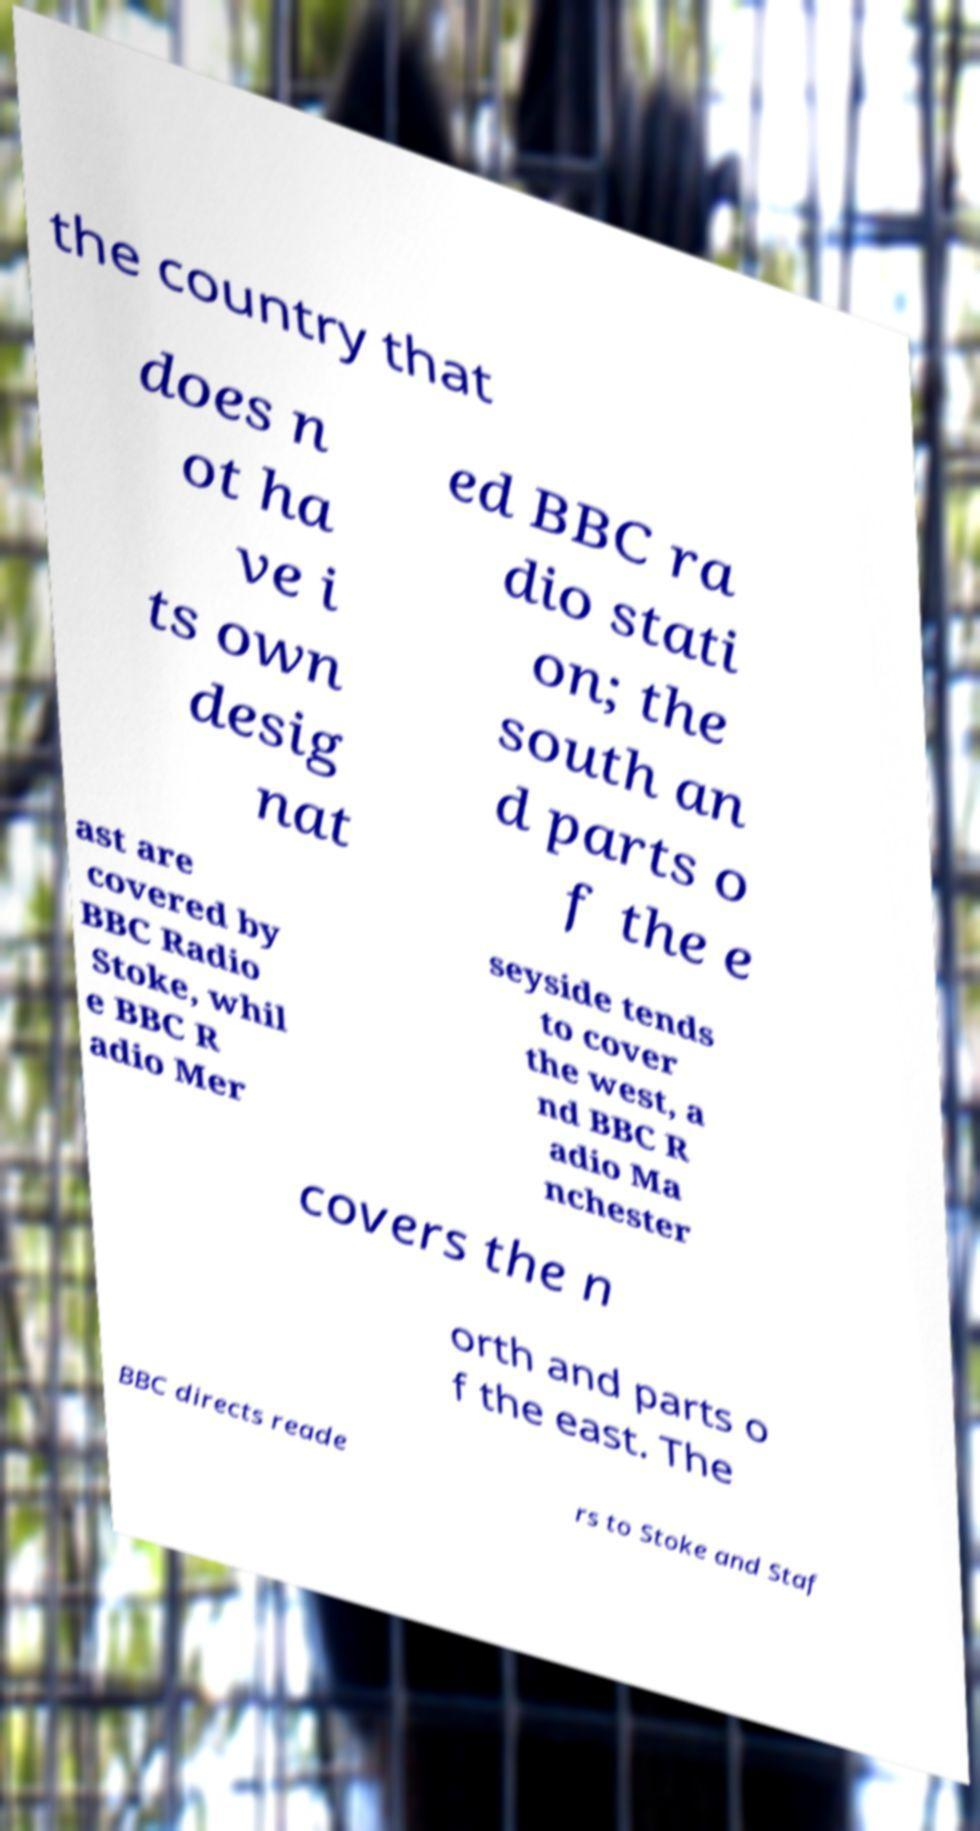Can you accurately transcribe the text from the provided image for me? the country that does n ot ha ve i ts own desig nat ed BBC ra dio stati on; the south an d parts o f the e ast are covered by BBC Radio Stoke, whil e BBC R adio Mer seyside tends to cover the west, a nd BBC R adio Ma nchester covers the n orth and parts o f the east. The BBC directs reade rs to Stoke and Staf 